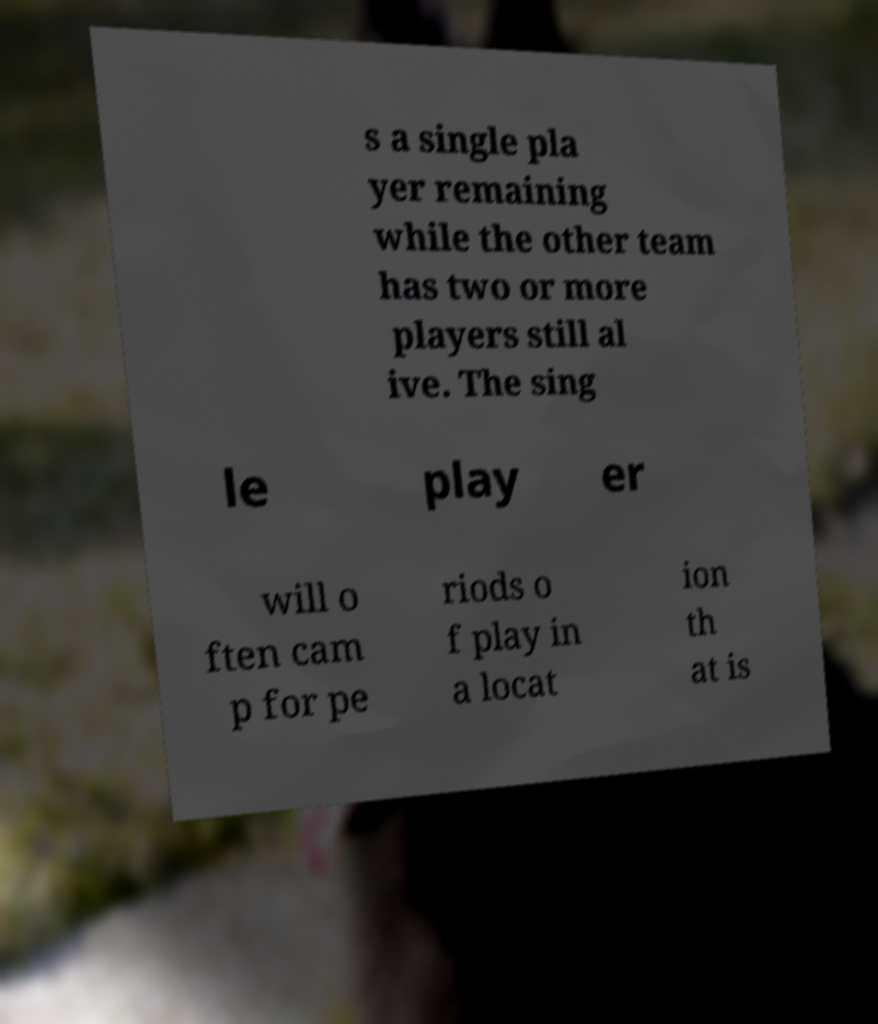There's text embedded in this image that I need extracted. Can you transcribe it verbatim? s a single pla yer remaining while the other team has two or more players still al ive. The sing le play er will o ften cam p for pe riods o f play in a locat ion th at is 